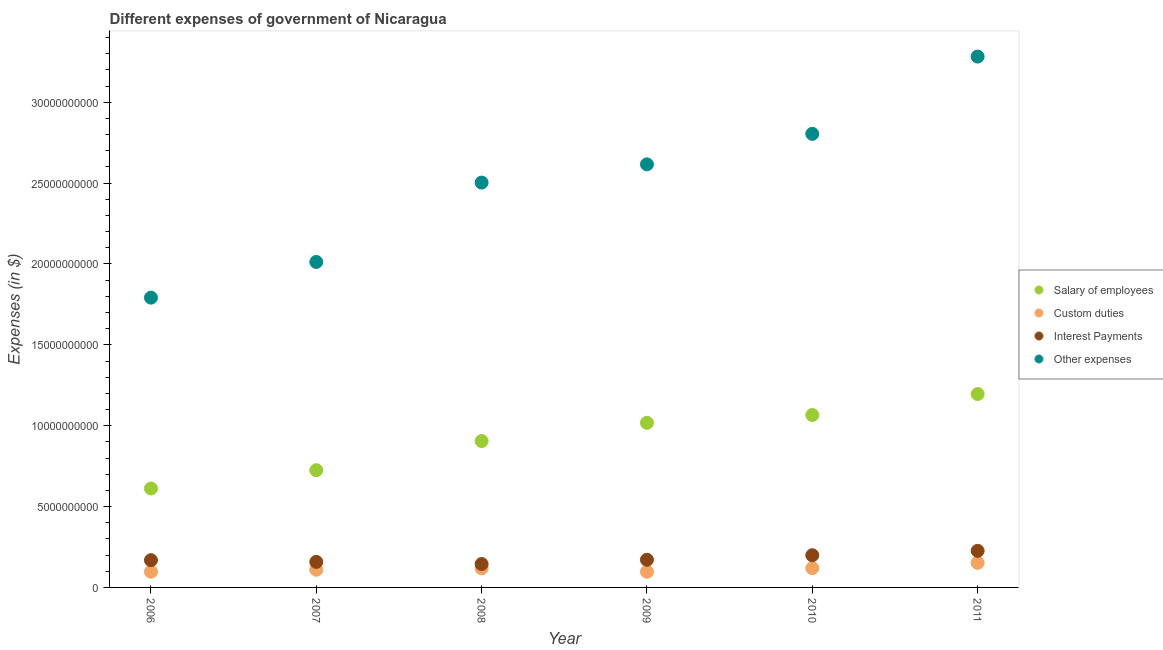How many different coloured dotlines are there?
Make the answer very short. 4. Is the number of dotlines equal to the number of legend labels?
Ensure brevity in your answer.  Yes. What is the amount spent on salary of employees in 2006?
Provide a succinct answer. 6.12e+09. Across all years, what is the maximum amount spent on salary of employees?
Offer a very short reply. 1.20e+1. Across all years, what is the minimum amount spent on salary of employees?
Keep it short and to the point. 6.12e+09. In which year was the amount spent on interest payments minimum?
Your answer should be very brief. 2008. What is the total amount spent on interest payments in the graph?
Keep it short and to the point. 1.07e+1. What is the difference between the amount spent on custom duties in 2006 and that in 2010?
Your answer should be very brief. -2.19e+08. What is the difference between the amount spent on interest payments in 2010 and the amount spent on salary of employees in 2006?
Make the answer very short. -4.13e+09. What is the average amount spent on custom duties per year?
Provide a short and direct response. 1.16e+09. In the year 2010, what is the difference between the amount spent on salary of employees and amount spent on interest payments?
Make the answer very short. 8.67e+09. In how many years, is the amount spent on salary of employees greater than 6000000000 $?
Make the answer very short. 6. What is the ratio of the amount spent on custom duties in 2006 to that in 2007?
Make the answer very short. 0.89. Is the amount spent on custom duties in 2009 less than that in 2011?
Your answer should be very brief. Yes. What is the difference between the highest and the second highest amount spent on custom duties?
Offer a terse response. 3.31e+08. What is the difference between the highest and the lowest amount spent on salary of employees?
Keep it short and to the point. 5.84e+09. In how many years, is the amount spent on salary of employees greater than the average amount spent on salary of employees taken over all years?
Your answer should be compact. 3. Is it the case that in every year, the sum of the amount spent on salary of employees and amount spent on other expenses is greater than the sum of amount spent on custom duties and amount spent on interest payments?
Your answer should be very brief. Yes. Is it the case that in every year, the sum of the amount spent on salary of employees and amount spent on custom duties is greater than the amount spent on interest payments?
Provide a short and direct response. Yes. Is the amount spent on custom duties strictly greater than the amount spent on other expenses over the years?
Provide a succinct answer. No. Is the amount spent on salary of employees strictly less than the amount spent on custom duties over the years?
Your response must be concise. No. How many dotlines are there?
Keep it short and to the point. 4. Are the values on the major ticks of Y-axis written in scientific E-notation?
Offer a very short reply. No. Does the graph contain any zero values?
Provide a short and direct response. No. How many legend labels are there?
Offer a terse response. 4. How are the legend labels stacked?
Your answer should be very brief. Vertical. What is the title of the graph?
Offer a very short reply. Different expenses of government of Nicaragua. Does "Grants and Revenue" appear as one of the legend labels in the graph?
Keep it short and to the point. No. What is the label or title of the X-axis?
Your answer should be compact. Year. What is the label or title of the Y-axis?
Offer a very short reply. Expenses (in $). What is the Expenses (in $) of Salary of employees in 2006?
Provide a succinct answer. 6.12e+09. What is the Expenses (in $) in Custom duties in 2006?
Provide a short and direct response. 9.72e+08. What is the Expenses (in $) in Interest Payments in 2006?
Your response must be concise. 1.68e+09. What is the Expenses (in $) in Other expenses in 2006?
Provide a short and direct response. 1.79e+1. What is the Expenses (in $) of Salary of employees in 2007?
Keep it short and to the point. 7.25e+09. What is the Expenses (in $) in Custom duties in 2007?
Give a very brief answer. 1.09e+09. What is the Expenses (in $) in Interest Payments in 2007?
Make the answer very short. 1.58e+09. What is the Expenses (in $) in Other expenses in 2007?
Offer a very short reply. 2.01e+1. What is the Expenses (in $) in Salary of employees in 2008?
Make the answer very short. 9.05e+09. What is the Expenses (in $) in Custom duties in 2008?
Make the answer very short. 1.18e+09. What is the Expenses (in $) in Interest Payments in 2008?
Offer a terse response. 1.45e+09. What is the Expenses (in $) in Other expenses in 2008?
Offer a terse response. 2.50e+1. What is the Expenses (in $) of Salary of employees in 2009?
Make the answer very short. 1.02e+1. What is the Expenses (in $) of Custom duties in 2009?
Your response must be concise. 9.70e+08. What is the Expenses (in $) in Interest Payments in 2009?
Keep it short and to the point. 1.71e+09. What is the Expenses (in $) in Other expenses in 2009?
Your response must be concise. 2.62e+1. What is the Expenses (in $) in Salary of employees in 2010?
Provide a succinct answer. 1.07e+1. What is the Expenses (in $) of Custom duties in 2010?
Provide a succinct answer. 1.19e+09. What is the Expenses (in $) of Interest Payments in 2010?
Make the answer very short. 1.99e+09. What is the Expenses (in $) in Other expenses in 2010?
Your response must be concise. 2.80e+1. What is the Expenses (in $) in Salary of employees in 2011?
Provide a succinct answer. 1.20e+1. What is the Expenses (in $) in Custom duties in 2011?
Offer a very short reply. 1.52e+09. What is the Expenses (in $) in Interest Payments in 2011?
Provide a succinct answer. 2.26e+09. What is the Expenses (in $) of Other expenses in 2011?
Give a very brief answer. 3.28e+1. Across all years, what is the maximum Expenses (in $) in Salary of employees?
Ensure brevity in your answer.  1.20e+1. Across all years, what is the maximum Expenses (in $) in Custom duties?
Offer a terse response. 1.52e+09. Across all years, what is the maximum Expenses (in $) of Interest Payments?
Provide a short and direct response. 2.26e+09. Across all years, what is the maximum Expenses (in $) of Other expenses?
Ensure brevity in your answer.  3.28e+1. Across all years, what is the minimum Expenses (in $) of Salary of employees?
Your answer should be compact. 6.12e+09. Across all years, what is the minimum Expenses (in $) in Custom duties?
Provide a short and direct response. 9.70e+08. Across all years, what is the minimum Expenses (in $) of Interest Payments?
Your answer should be compact. 1.45e+09. Across all years, what is the minimum Expenses (in $) in Other expenses?
Give a very brief answer. 1.79e+1. What is the total Expenses (in $) of Salary of employees in the graph?
Give a very brief answer. 5.52e+1. What is the total Expenses (in $) of Custom duties in the graph?
Provide a succinct answer. 6.93e+09. What is the total Expenses (in $) in Interest Payments in the graph?
Your answer should be very brief. 1.07e+1. What is the total Expenses (in $) of Other expenses in the graph?
Offer a terse response. 1.50e+11. What is the difference between the Expenses (in $) of Salary of employees in 2006 and that in 2007?
Your response must be concise. -1.13e+09. What is the difference between the Expenses (in $) in Custom duties in 2006 and that in 2007?
Make the answer very short. -1.21e+08. What is the difference between the Expenses (in $) in Interest Payments in 2006 and that in 2007?
Provide a short and direct response. 1.05e+08. What is the difference between the Expenses (in $) in Other expenses in 2006 and that in 2007?
Make the answer very short. -2.21e+09. What is the difference between the Expenses (in $) in Salary of employees in 2006 and that in 2008?
Ensure brevity in your answer.  -2.93e+09. What is the difference between the Expenses (in $) of Custom duties in 2006 and that in 2008?
Make the answer very short. -2.11e+08. What is the difference between the Expenses (in $) in Interest Payments in 2006 and that in 2008?
Your answer should be very brief. 2.37e+08. What is the difference between the Expenses (in $) of Other expenses in 2006 and that in 2008?
Offer a terse response. -7.11e+09. What is the difference between the Expenses (in $) in Salary of employees in 2006 and that in 2009?
Provide a succinct answer. -4.06e+09. What is the difference between the Expenses (in $) in Custom duties in 2006 and that in 2009?
Give a very brief answer. 1.82e+06. What is the difference between the Expenses (in $) of Interest Payments in 2006 and that in 2009?
Ensure brevity in your answer.  -2.69e+07. What is the difference between the Expenses (in $) of Other expenses in 2006 and that in 2009?
Ensure brevity in your answer.  -8.24e+09. What is the difference between the Expenses (in $) in Salary of employees in 2006 and that in 2010?
Provide a short and direct response. -4.54e+09. What is the difference between the Expenses (in $) in Custom duties in 2006 and that in 2010?
Provide a succinct answer. -2.19e+08. What is the difference between the Expenses (in $) in Interest Payments in 2006 and that in 2010?
Keep it short and to the point. -3.06e+08. What is the difference between the Expenses (in $) in Other expenses in 2006 and that in 2010?
Offer a very short reply. -1.01e+1. What is the difference between the Expenses (in $) of Salary of employees in 2006 and that in 2011?
Make the answer very short. -5.84e+09. What is the difference between the Expenses (in $) of Custom duties in 2006 and that in 2011?
Offer a very short reply. -5.50e+08. What is the difference between the Expenses (in $) of Interest Payments in 2006 and that in 2011?
Give a very brief answer. -5.78e+08. What is the difference between the Expenses (in $) of Other expenses in 2006 and that in 2011?
Offer a very short reply. -1.49e+1. What is the difference between the Expenses (in $) of Salary of employees in 2007 and that in 2008?
Give a very brief answer. -1.80e+09. What is the difference between the Expenses (in $) of Custom duties in 2007 and that in 2008?
Your answer should be compact. -8.99e+07. What is the difference between the Expenses (in $) in Interest Payments in 2007 and that in 2008?
Make the answer very short. 1.32e+08. What is the difference between the Expenses (in $) in Other expenses in 2007 and that in 2008?
Provide a short and direct response. -4.91e+09. What is the difference between the Expenses (in $) of Salary of employees in 2007 and that in 2009?
Ensure brevity in your answer.  -2.93e+09. What is the difference between the Expenses (in $) of Custom duties in 2007 and that in 2009?
Offer a very short reply. 1.23e+08. What is the difference between the Expenses (in $) of Interest Payments in 2007 and that in 2009?
Offer a terse response. -1.31e+08. What is the difference between the Expenses (in $) in Other expenses in 2007 and that in 2009?
Your answer should be very brief. -6.03e+09. What is the difference between the Expenses (in $) in Salary of employees in 2007 and that in 2010?
Ensure brevity in your answer.  -3.41e+09. What is the difference between the Expenses (in $) of Custom duties in 2007 and that in 2010?
Make the answer very short. -9.75e+07. What is the difference between the Expenses (in $) of Interest Payments in 2007 and that in 2010?
Offer a terse response. -4.11e+08. What is the difference between the Expenses (in $) in Other expenses in 2007 and that in 2010?
Your answer should be very brief. -7.92e+09. What is the difference between the Expenses (in $) in Salary of employees in 2007 and that in 2011?
Your response must be concise. -4.71e+09. What is the difference between the Expenses (in $) in Custom duties in 2007 and that in 2011?
Your answer should be compact. -4.29e+08. What is the difference between the Expenses (in $) of Interest Payments in 2007 and that in 2011?
Provide a short and direct response. -6.82e+08. What is the difference between the Expenses (in $) of Other expenses in 2007 and that in 2011?
Make the answer very short. -1.27e+1. What is the difference between the Expenses (in $) in Salary of employees in 2008 and that in 2009?
Keep it short and to the point. -1.13e+09. What is the difference between the Expenses (in $) of Custom duties in 2008 and that in 2009?
Make the answer very short. 2.13e+08. What is the difference between the Expenses (in $) of Interest Payments in 2008 and that in 2009?
Ensure brevity in your answer.  -2.64e+08. What is the difference between the Expenses (in $) in Other expenses in 2008 and that in 2009?
Offer a terse response. -1.13e+09. What is the difference between the Expenses (in $) in Salary of employees in 2008 and that in 2010?
Provide a short and direct response. -1.61e+09. What is the difference between the Expenses (in $) in Custom duties in 2008 and that in 2010?
Give a very brief answer. -7.60e+06. What is the difference between the Expenses (in $) in Interest Payments in 2008 and that in 2010?
Offer a terse response. -5.43e+08. What is the difference between the Expenses (in $) of Other expenses in 2008 and that in 2010?
Keep it short and to the point. -3.01e+09. What is the difference between the Expenses (in $) in Salary of employees in 2008 and that in 2011?
Your answer should be compact. -2.91e+09. What is the difference between the Expenses (in $) in Custom duties in 2008 and that in 2011?
Make the answer very short. -3.39e+08. What is the difference between the Expenses (in $) in Interest Payments in 2008 and that in 2011?
Offer a very short reply. -8.14e+08. What is the difference between the Expenses (in $) of Other expenses in 2008 and that in 2011?
Keep it short and to the point. -7.79e+09. What is the difference between the Expenses (in $) in Salary of employees in 2009 and that in 2010?
Make the answer very short. -4.83e+08. What is the difference between the Expenses (in $) in Custom duties in 2009 and that in 2010?
Offer a very short reply. -2.21e+08. What is the difference between the Expenses (in $) of Interest Payments in 2009 and that in 2010?
Your response must be concise. -2.79e+08. What is the difference between the Expenses (in $) of Other expenses in 2009 and that in 2010?
Ensure brevity in your answer.  -1.89e+09. What is the difference between the Expenses (in $) of Salary of employees in 2009 and that in 2011?
Ensure brevity in your answer.  -1.78e+09. What is the difference between the Expenses (in $) of Custom duties in 2009 and that in 2011?
Keep it short and to the point. -5.52e+08. What is the difference between the Expenses (in $) in Interest Payments in 2009 and that in 2011?
Provide a short and direct response. -5.51e+08. What is the difference between the Expenses (in $) in Other expenses in 2009 and that in 2011?
Make the answer very short. -6.66e+09. What is the difference between the Expenses (in $) of Salary of employees in 2010 and that in 2011?
Ensure brevity in your answer.  -1.30e+09. What is the difference between the Expenses (in $) in Custom duties in 2010 and that in 2011?
Provide a succinct answer. -3.31e+08. What is the difference between the Expenses (in $) in Interest Payments in 2010 and that in 2011?
Offer a very short reply. -2.71e+08. What is the difference between the Expenses (in $) of Other expenses in 2010 and that in 2011?
Your answer should be compact. -4.78e+09. What is the difference between the Expenses (in $) of Salary of employees in 2006 and the Expenses (in $) of Custom duties in 2007?
Offer a very short reply. 5.02e+09. What is the difference between the Expenses (in $) of Salary of employees in 2006 and the Expenses (in $) of Interest Payments in 2007?
Provide a succinct answer. 4.54e+09. What is the difference between the Expenses (in $) of Salary of employees in 2006 and the Expenses (in $) of Other expenses in 2007?
Provide a short and direct response. -1.40e+1. What is the difference between the Expenses (in $) in Custom duties in 2006 and the Expenses (in $) in Interest Payments in 2007?
Give a very brief answer. -6.08e+08. What is the difference between the Expenses (in $) of Custom duties in 2006 and the Expenses (in $) of Other expenses in 2007?
Make the answer very short. -1.92e+1. What is the difference between the Expenses (in $) of Interest Payments in 2006 and the Expenses (in $) of Other expenses in 2007?
Your answer should be compact. -1.84e+1. What is the difference between the Expenses (in $) in Salary of employees in 2006 and the Expenses (in $) in Custom duties in 2008?
Keep it short and to the point. 4.93e+09. What is the difference between the Expenses (in $) of Salary of employees in 2006 and the Expenses (in $) of Interest Payments in 2008?
Offer a terse response. 4.67e+09. What is the difference between the Expenses (in $) of Salary of employees in 2006 and the Expenses (in $) of Other expenses in 2008?
Your response must be concise. -1.89e+1. What is the difference between the Expenses (in $) in Custom duties in 2006 and the Expenses (in $) in Interest Payments in 2008?
Keep it short and to the point. -4.75e+08. What is the difference between the Expenses (in $) in Custom duties in 2006 and the Expenses (in $) in Other expenses in 2008?
Provide a short and direct response. -2.41e+1. What is the difference between the Expenses (in $) of Interest Payments in 2006 and the Expenses (in $) of Other expenses in 2008?
Make the answer very short. -2.33e+1. What is the difference between the Expenses (in $) in Salary of employees in 2006 and the Expenses (in $) in Custom duties in 2009?
Ensure brevity in your answer.  5.15e+09. What is the difference between the Expenses (in $) in Salary of employees in 2006 and the Expenses (in $) in Interest Payments in 2009?
Your answer should be very brief. 4.41e+09. What is the difference between the Expenses (in $) in Salary of employees in 2006 and the Expenses (in $) in Other expenses in 2009?
Make the answer very short. -2.00e+1. What is the difference between the Expenses (in $) of Custom duties in 2006 and the Expenses (in $) of Interest Payments in 2009?
Ensure brevity in your answer.  -7.39e+08. What is the difference between the Expenses (in $) of Custom duties in 2006 and the Expenses (in $) of Other expenses in 2009?
Give a very brief answer. -2.52e+1. What is the difference between the Expenses (in $) of Interest Payments in 2006 and the Expenses (in $) of Other expenses in 2009?
Keep it short and to the point. -2.45e+1. What is the difference between the Expenses (in $) in Salary of employees in 2006 and the Expenses (in $) in Custom duties in 2010?
Ensure brevity in your answer.  4.93e+09. What is the difference between the Expenses (in $) in Salary of employees in 2006 and the Expenses (in $) in Interest Payments in 2010?
Offer a terse response. 4.13e+09. What is the difference between the Expenses (in $) in Salary of employees in 2006 and the Expenses (in $) in Other expenses in 2010?
Offer a very short reply. -2.19e+1. What is the difference between the Expenses (in $) of Custom duties in 2006 and the Expenses (in $) of Interest Payments in 2010?
Keep it short and to the point. -1.02e+09. What is the difference between the Expenses (in $) in Custom duties in 2006 and the Expenses (in $) in Other expenses in 2010?
Give a very brief answer. -2.71e+1. What is the difference between the Expenses (in $) in Interest Payments in 2006 and the Expenses (in $) in Other expenses in 2010?
Your answer should be compact. -2.64e+1. What is the difference between the Expenses (in $) in Salary of employees in 2006 and the Expenses (in $) in Custom duties in 2011?
Your answer should be compact. 4.60e+09. What is the difference between the Expenses (in $) in Salary of employees in 2006 and the Expenses (in $) in Interest Payments in 2011?
Offer a terse response. 3.86e+09. What is the difference between the Expenses (in $) of Salary of employees in 2006 and the Expenses (in $) of Other expenses in 2011?
Provide a succinct answer. -2.67e+1. What is the difference between the Expenses (in $) in Custom duties in 2006 and the Expenses (in $) in Interest Payments in 2011?
Offer a terse response. -1.29e+09. What is the difference between the Expenses (in $) in Custom duties in 2006 and the Expenses (in $) in Other expenses in 2011?
Provide a short and direct response. -3.19e+1. What is the difference between the Expenses (in $) in Interest Payments in 2006 and the Expenses (in $) in Other expenses in 2011?
Provide a succinct answer. -3.11e+1. What is the difference between the Expenses (in $) in Salary of employees in 2007 and the Expenses (in $) in Custom duties in 2008?
Your response must be concise. 6.06e+09. What is the difference between the Expenses (in $) in Salary of employees in 2007 and the Expenses (in $) in Interest Payments in 2008?
Offer a very short reply. 5.80e+09. What is the difference between the Expenses (in $) of Salary of employees in 2007 and the Expenses (in $) of Other expenses in 2008?
Keep it short and to the point. -1.78e+1. What is the difference between the Expenses (in $) of Custom duties in 2007 and the Expenses (in $) of Interest Payments in 2008?
Keep it short and to the point. -3.54e+08. What is the difference between the Expenses (in $) in Custom duties in 2007 and the Expenses (in $) in Other expenses in 2008?
Give a very brief answer. -2.39e+1. What is the difference between the Expenses (in $) in Interest Payments in 2007 and the Expenses (in $) in Other expenses in 2008?
Make the answer very short. -2.35e+1. What is the difference between the Expenses (in $) of Salary of employees in 2007 and the Expenses (in $) of Custom duties in 2009?
Offer a terse response. 6.28e+09. What is the difference between the Expenses (in $) in Salary of employees in 2007 and the Expenses (in $) in Interest Payments in 2009?
Your response must be concise. 5.54e+09. What is the difference between the Expenses (in $) of Salary of employees in 2007 and the Expenses (in $) of Other expenses in 2009?
Your response must be concise. -1.89e+1. What is the difference between the Expenses (in $) of Custom duties in 2007 and the Expenses (in $) of Interest Payments in 2009?
Make the answer very short. -6.18e+08. What is the difference between the Expenses (in $) of Custom duties in 2007 and the Expenses (in $) of Other expenses in 2009?
Give a very brief answer. -2.51e+1. What is the difference between the Expenses (in $) of Interest Payments in 2007 and the Expenses (in $) of Other expenses in 2009?
Your response must be concise. -2.46e+1. What is the difference between the Expenses (in $) of Salary of employees in 2007 and the Expenses (in $) of Custom duties in 2010?
Ensure brevity in your answer.  6.06e+09. What is the difference between the Expenses (in $) in Salary of employees in 2007 and the Expenses (in $) in Interest Payments in 2010?
Your answer should be very brief. 5.26e+09. What is the difference between the Expenses (in $) in Salary of employees in 2007 and the Expenses (in $) in Other expenses in 2010?
Keep it short and to the point. -2.08e+1. What is the difference between the Expenses (in $) in Custom duties in 2007 and the Expenses (in $) in Interest Payments in 2010?
Offer a very short reply. -8.97e+08. What is the difference between the Expenses (in $) of Custom duties in 2007 and the Expenses (in $) of Other expenses in 2010?
Give a very brief answer. -2.70e+1. What is the difference between the Expenses (in $) of Interest Payments in 2007 and the Expenses (in $) of Other expenses in 2010?
Offer a terse response. -2.65e+1. What is the difference between the Expenses (in $) of Salary of employees in 2007 and the Expenses (in $) of Custom duties in 2011?
Give a very brief answer. 5.73e+09. What is the difference between the Expenses (in $) in Salary of employees in 2007 and the Expenses (in $) in Interest Payments in 2011?
Ensure brevity in your answer.  4.99e+09. What is the difference between the Expenses (in $) in Salary of employees in 2007 and the Expenses (in $) in Other expenses in 2011?
Provide a short and direct response. -2.56e+1. What is the difference between the Expenses (in $) in Custom duties in 2007 and the Expenses (in $) in Interest Payments in 2011?
Ensure brevity in your answer.  -1.17e+09. What is the difference between the Expenses (in $) in Custom duties in 2007 and the Expenses (in $) in Other expenses in 2011?
Your response must be concise. -3.17e+1. What is the difference between the Expenses (in $) in Interest Payments in 2007 and the Expenses (in $) in Other expenses in 2011?
Your answer should be very brief. -3.12e+1. What is the difference between the Expenses (in $) in Salary of employees in 2008 and the Expenses (in $) in Custom duties in 2009?
Keep it short and to the point. 8.08e+09. What is the difference between the Expenses (in $) of Salary of employees in 2008 and the Expenses (in $) of Interest Payments in 2009?
Ensure brevity in your answer.  7.34e+09. What is the difference between the Expenses (in $) in Salary of employees in 2008 and the Expenses (in $) in Other expenses in 2009?
Give a very brief answer. -1.71e+1. What is the difference between the Expenses (in $) of Custom duties in 2008 and the Expenses (in $) of Interest Payments in 2009?
Give a very brief answer. -5.28e+08. What is the difference between the Expenses (in $) in Custom duties in 2008 and the Expenses (in $) in Other expenses in 2009?
Offer a very short reply. -2.50e+1. What is the difference between the Expenses (in $) of Interest Payments in 2008 and the Expenses (in $) of Other expenses in 2009?
Your response must be concise. -2.47e+1. What is the difference between the Expenses (in $) of Salary of employees in 2008 and the Expenses (in $) of Custom duties in 2010?
Provide a short and direct response. 7.86e+09. What is the difference between the Expenses (in $) of Salary of employees in 2008 and the Expenses (in $) of Interest Payments in 2010?
Offer a terse response. 7.06e+09. What is the difference between the Expenses (in $) of Salary of employees in 2008 and the Expenses (in $) of Other expenses in 2010?
Keep it short and to the point. -1.90e+1. What is the difference between the Expenses (in $) of Custom duties in 2008 and the Expenses (in $) of Interest Payments in 2010?
Offer a very short reply. -8.07e+08. What is the difference between the Expenses (in $) of Custom duties in 2008 and the Expenses (in $) of Other expenses in 2010?
Your answer should be very brief. -2.69e+1. What is the difference between the Expenses (in $) of Interest Payments in 2008 and the Expenses (in $) of Other expenses in 2010?
Your response must be concise. -2.66e+1. What is the difference between the Expenses (in $) of Salary of employees in 2008 and the Expenses (in $) of Custom duties in 2011?
Keep it short and to the point. 7.53e+09. What is the difference between the Expenses (in $) in Salary of employees in 2008 and the Expenses (in $) in Interest Payments in 2011?
Provide a succinct answer. 6.79e+09. What is the difference between the Expenses (in $) of Salary of employees in 2008 and the Expenses (in $) of Other expenses in 2011?
Ensure brevity in your answer.  -2.38e+1. What is the difference between the Expenses (in $) of Custom duties in 2008 and the Expenses (in $) of Interest Payments in 2011?
Ensure brevity in your answer.  -1.08e+09. What is the difference between the Expenses (in $) in Custom duties in 2008 and the Expenses (in $) in Other expenses in 2011?
Your response must be concise. -3.16e+1. What is the difference between the Expenses (in $) in Interest Payments in 2008 and the Expenses (in $) in Other expenses in 2011?
Provide a succinct answer. -3.14e+1. What is the difference between the Expenses (in $) in Salary of employees in 2009 and the Expenses (in $) in Custom duties in 2010?
Give a very brief answer. 8.99e+09. What is the difference between the Expenses (in $) in Salary of employees in 2009 and the Expenses (in $) in Interest Payments in 2010?
Provide a short and direct response. 8.19e+09. What is the difference between the Expenses (in $) of Salary of employees in 2009 and the Expenses (in $) of Other expenses in 2010?
Offer a very short reply. -1.79e+1. What is the difference between the Expenses (in $) in Custom duties in 2009 and the Expenses (in $) in Interest Payments in 2010?
Make the answer very short. -1.02e+09. What is the difference between the Expenses (in $) in Custom duties in 2009 and the Expenses (in $) in Other expenses in 2010?
Give a very brief answer. -2.71e+1. What is the difference between the Expenses (in $) in Interest Payments in 2009 and the Expenses (in $) in Other expenses in 2010?
Your answer should be very brief. -2.63e+1. What is the difference between the Expenses (in $) of Salary of employees in 2009 and the Expenses (in $) of Custom duties in 2011?
Provide a succinct answer. 8.66e+09. What is the difference between the Expenses (in $) of Salary of employees in 2009 and the Expenses (in $) of Interest Payments in 2011?
Provide a succinct answer. 7.92e+09. What is the difference between the Expenses (in $) in Salary of employees in 2009 and the Expenses (in $) in Other expenses in 2011?
Provide a succinct answer. -2.26e+1. What is the difference between the Expenses (in $) in Custom duties in 2009 and the Expenses (in $) in Interest Payments in 2011?
Your response must be concise. -1.29e+09. What is the difference between the Expenses (in $) in Custom duties in 2009 and the Expenses (in $) in Other expenses in 2011?
Provide a short and direct response. -3.19e+1. What is the difference between the Expenses (in $) in Interest Payments in 2009 and the Expenses (in $) in Other expenses in 2011?
Offer a very short reply. -3.11e+1. What is the difference between the Expenses (in $) of Salary of employees in 2010 and the Expenses (in $) of Custom duties in 2011?
Give a very brief answer. 9.14e+09. What is the difference between the Expenses (in $) of Salary of employees in 2010 and the Expenses (in $) of Interest Payments in 2011?
Offer a very short reply. 8.40e+09. What is the difference between the Expenses (in $) of Salary of employees in 2010 and the Expenses (in $) of Other expenses in 2011?
Your response must be concise. -2.22e+1. What is the difference between the Expenses (in $) in Custom duties in 2010 and the Expenses (in $) in Interest Payments in 2011?
Offer a very short reply. -1.07e+09. What is the difference between the Expenses (in $) in Custom duties in 2010 and the Expenses (in $) in Other expenses in 2011?
Your answer should be compact. -3.16e+1. What is the difference between the Expenses (in $) in Interest Payments in 2010 and the Expenses (in $) in Other expenses in 2011?
Your response must be concise. -3.08e+1. What is the average Expenses (in $) of Salary of employees per year?
Make the answer very short. 9.20e+09. What is the average Expenses (in $) in Custom duties per year?
Your answer should be very brief. 1.16e+09. What is the average Expenses (in $) of Interest Payments per year?
Your answer should be very brief. 1.78e+09. What is the average Expenses (in $) in Other expenses per year?
Provide a succinct answer. 2.50e+1. In the year 2006, what is the difference between the Expenses (in $) in Salary of employees and Expenses (in $) in Custom duties?
Your answer should be compact. 5.15e+09. In the year 2006, what is the difference between the Expenses (in $) in Salary of employees and Expenses (in $) in Interest Payments?
Your answer should be very brief. 4.43e+09. In the year 2006, what is the difference between the Expenses (in $) of Salary of employees and Expenses (in $) of Other expenses?
Offer a terse response. -1.18e+1. In the year 2006, what is the difference between the Expenses (in $) of Custom duties and Expenses (in $) of Interest Payments?
Provide a short and direct response. -7.12e+08. In the year 2006, what is the difference between the Expenses (in $) in Custom duties and Expenses (in $) in Other expenses?
Your answer should be compact. -1.69e+1. In the year 2006, what is the difference between the Expenses (in $) in Interest Payments and Expenses (in $) in Other expenses?
Your answer should be compact. -1.62e+1. In the year 2007, what is the difference between the Expenses (in $) in Salary of employees and Expenses (in $) in Custom duties?
Ensure brevity in your answer.  6.15e+09. In the year 2007, what is the difference between the Expenses (in $) in Salary of employees and Expenses (in $) in Interest Payments?
Keep it short and to the point. 5.67e+09. In the year 2007, what is the difference between the Expenses (in $) of Salary of employees and Expenses (in $) of Other expenses?
Make the answer very short. -1.29e+1. In the year 2007, what is the difference between the Expenses (in $) in Custom duties and Expenses (in $) in Interest Payments?
Ensure brevity in your answer.  -4.86e+08. In the year 2007, what is the difference between the Expenses (in $) of Custom duties and Expenses (in $) of Other expenses?
Keep it short and to the point. -1.90e+1. In the year 2007, what is the difference between the Expenses (in $) of Interest Payments and Expenses (in $) of Other expenses?
Give a very brief answer. -1.85e+1. In the year 2008, what is the difference between the Expenses (in $) in Salary of employees and Expenses (in $) in Custom duties?
Make the answer very short. 7.87e+09. In the year 2008, what is the difference between the Expenses (in $) of Salary of employees and Expenses (in $) of Interest Payments?
Ensure brevity in your answer.  7.60e+09. In the year 2008, what is the difference between the Expenses (in $) of Salary of employees and Expenses (in $) of Other expenses?
Your answer should be very brief. -1.60e+1. In the year 2008, what is the difference between the Expenses (in $) in Custom duties and Expenses (in $) in Interest Payments?
Your response must be concise. -2.64e+08. In the year 2008, what is the difference between the Expenses (in $) of Custom duties and Expenses (in $) of Other expenses?
Ensure brevity in your answer.  -2.38e+1. In the year 2008, what is the difference between the Expenses (in $) of Interest Payments and Expenses (in $) of Other expenses?
Make the answer very short. -2.36e+1. In the year 2009, what is the difference between the Expenses (in $) of Salary of employees and Expenses (in $) of Custom duties?
Provide a short and direct response. 9.21e+09. In the year 2009, what is the difference between the Expenses (in $) in Salary of employees and Expenses (in $) in Interest Payments?
Offer a terse response. 8.47e+09. In the year 2009, what is the difference between the Expenses (in $) of Salary of employees and Expenses (in $) of Other expenses?
Provide a short and direct response. -1.60e+1. In the year 2009, what is the difference between the Expenses (in $) in Custom duties and Expenses (in $) in Interest Payments?
Your answer should be compact. -7.41e+08. In the year 2009, what is the difference between the Expenses (in $) in Custom duties and Expenses (in $) in Other expenses?
Offer a terse response. -2.52e+1. In the year 2009, what is the difference between the Expenses (in $) in Interest Payments and Expenses (in $) in Other expenses?
Make the answer very short. -2.44e+1. In the year 2010, what is the difference between the Expenses (in $) in Salary of employees and Expenses (in $) in Custom duties?
Provide a succinct answer. 9.47e+09. In the year 2010, what is the difference between the Expenses (in $) in Salary of employees and Expenses (in $) in Interest Payments?
Your answer should be very brief. 8.67e+09. In the year 2010, what is the difference between the Expenses (in $) in Salary of employees and Expenses (in $) in Other expenses?
Your response must be concise. -1.74e+1. In the year 2010, what is the difference between the Expenses (in $) in Custom duties and Expenses (in $) in Interest Payments?
Your response must be concise. -8.00e+08. In the year 2010, what is the difference between the Expenses (in $) of Custom duties and Expenses (in $) of Other expenses?
Offer a very short reply. -2.69e+1. In the year 2010, what is the difference between the Expenses (in $) of Interest Payments and Expenses (in $) of Other expenses?
Your answer should be very brief. -2.61e+1. In the year 2011, what is the difference between the Expenses (in $) in Salary of employees and Expenses (in $) in Custom duties?
Offer a very short reply. 1.04e+1. In the year 2011, what is the difference between the Expenses (in $) in Salary of employees and Expenses (in $) in Interest Payments?
Your answer should be compact. 9.70e+09. In the year 2011, what is the difference between the Expenses (in $) in Salary of employees and Expenses (in $) in Other expenses?
Offer a very short reply. -2.09e+1. In the year 2011, what is the difference between the Expenses (in $) in Custom duties and Expenses (in $) in Interest Payments?
Your answer should be compact. -7.40e+08. In the year 2011, what is the difference between the Expenses (in $) in Custom duties and Expenses (in $) in Other expenses?
Keep it short and to the point. -3.13e+1. In the year 2011, what is the difference between the Expenses (in $) in Interest Payments and Expenses (in $) in Other expenses?
Your answer should be very brief. -3.06e+1. What is the ratio of the Expenses (in $) of Salary of employees in 2006 to that in 2007?
Ensure brevity in your answer.  0.84. What is the ratio of the Expenses (in $) in Custom duties in 2006 to that in 2007?
Your answer should be very brief. 0.89. What is the ratio of the Expenses (in $) of Interest Payments in 2006 to that in 2007?
Give a very brief answer. 1.07. What is the ratio of the Expenses (in $) of Other expenses in 2006 to that in 2007?
Your answer should be very brief. 0.89. What is the ratio of the Expenses (in $) in Salary of employees in 2006 to that in 2008?
Keep it short and to the point. 0.68. What is the ratio of the Expenses (in $) in Custom duties in 2006 to that in 2008?
Provide a succinct answer. 0.82. What is the ratio of the Expenses (in $) of Interest Payments in 2006 to that in 2008?
Keep it short and to the point. 1.16. What is the ratio of the Expenses (in $) in Other expenses in 2006 to that in 2008?
Provide a short and direct response. 0.72. What is the ratio of the Expenses (in $) of Salary of employees in 2006 to that in 2009?
Provide a short and direct response. 0.6. What is the ratio of the Expenses (in $) in Interest Payments in 2006 to that in 2009?
Provide a short and direct response. 0.98. What is the ratio of the Expenses (in $) in Other expenses in 2006 to that in 2009?
Offer a terse response. 0.69. What is the ratio of the Expenses (in $) of Salary of employees in 2006 to that in 2010?
Ensure brevity in your answer.  0.57. What is the ratio of the Expenses (in $) in Custom duties in 2006 to that in 2010?
Offer a terse response. 0.82. What is the ratio of the Expenses (in $) in Interest Payments in 2006 to that in 2010?
Offer a very short reply. 0.85. What is the ratio of the Expenses (in $) in Other expenses in 2006 to that in 2010?
Your answer should be compact. 0.64. What is the ratio of the Expenses (in $) in Salary of employees in 2006 to that in 2011?
Provide a short and direct response. 0.51. What is the ratio of the Expenses (in $) in Custom duties in 2006 to that in 2011?
Make the answer very short. 0.64. What is the ratio of the Expenses (in $) of Interest Payments in 2006 to that in 2011?
Offer a terse response. 0.74. What is the ratio of the Expenses (in $) in Other expenses in 2006 to that in 2011?
Your response must be concise. 0.55. What is the ratio of the Expenses (in $) of Salary of employees in 2007 to that in 2008?
Your answer should be very brief. 0.8. What is the ratio of the Expenses (in $) in Custom duties in 2007 to that in 2008?
Make the answer very short. 0.92. What is the ratio of the Expenses (in $) of Interest Payments in 2007 to that in 2008?
Offer a very short reply. 1.09. What is the ratio of the Expenses (in $) in Other expenses in 2007 to that in 2008?
Your answer should be compact. 0.8. What is the ratio of the Expenses (in $) of Salary of employees in 2007 to that in 2009?
Give a very brief answer. 0.71. What is the ratio of the Expenses (in $) in Custom duties in 2007 to that in 2009?
Provide a short and direct response. 1.13. What is the ratio of the Expenses (in $) of Interest Payments in 2007 to that in 2009?
Your response must be concise. 0.92. What is the ratio of the Expenses (in $) of Other expenses in 2007 to that in 2009?
Make the answer very short. 0.77. What is the ratio of the Expenses (in $) of Salary of employees in 2007 to that in 2010?
Give a very brief answer. 0.68. What is the ratio of the Expenses (in $) of Custom duties in 2007 to that in 2010?
Keep it short and to the point. 0.92. What is the ratio of the Expenses (in $) of Interest Payments in 2007 to that in 2010?
Provide a succinct answer. 0.79. What is the ratio of the Expenses (in $) of Other expenses in 2007 to that in 2010?
Provide a short and direct response. 0.72. What is the ratio of the Expenses (in $) in Salary of employees in 2007 to that in 2011?
Provide a succinct answer. 0.61. What is the ratio of the Expenses (in $) in Custom duties in 2007 to that in 2011?
Ensure brevity in your answer.  0.72. What is the ratio of the Expenses (in $) of Interest Payments in 2007 to that in 2011?
Your answer should be compact. 0.7. What is the ratio of the Expenses (in $) in Other expenses in 2007 to that in 2011?
Your answer should be compact. 0.61. What is the ratio of the Expenses (in $) in Salary of employees in 2008 to that in 2009?
Provide a short and direct response. 0.89. What is the ratio of the Expenses (in $) of Custom duties in 2008 to that in 2009?
Ensure brevity in your answer.  1.22. What is the ratio of the Expenses (in $) of Interest Payments in 2008 to that in 2009?
Offer a terse response. 0.85. What is the ratio of the Expenses (in $) in Other expenses in 2008 to that in 2009?
Your answer should be compact. 0.96. What is the ratio of the Expenses (in $) in Salary of employees in 2008 to that in 2010?
Provide a short and direct response. 0.85. What is the ratio of the Expenses (in $) of Interest Payments in 2008 to that in 2010?
Offer a terse response. 0.73. What is the ratio of the Expenses (in $) in Other expenses in 2008 to that in 2010?
Provide a short and direct response. 0.89. What is the ratio of the Expenses (in $) in Salary of employees in 2008 to that in 2011?
Provide a succinct answer. 0.76. What is the ratio of the Expenses (in $) of Custom duties in 2008 to that in 2011?
Provide a succinct answer. 0.78. What is the ratio of the Expenses (in $) in Interest Payments in 2008 to that in 2011?
Ensure brevity in your answer.  0.64. What is the ratio of the Expenses (in $) of Other expenses in 2008 to that in 2011?
Provide a short and direct response. 0.76. What is the ratio of the Expenses (in $) in Salary of employees in 2009 to that in 2010?
Ensure brevity in your answer.  0.95. What is the ratio of the Expenses (in $) of Custom duties in 2009 to that in 2010?
Keep it short and to the point. 0.81. What is the ratio of the Expenses (in $) in Interest Payments in 2009 to that in 2010?
Make the answer very short. 0.86. What is the ratio of the Expenses (in $) in Other expenses in 2009 to that in 2010?
Offer a very short reply. 0.93. What is the ratio of the Expenses (in $) of Salary of employees in 2009 to that in 2011?
Ensure brevity in your answer.  0.85. What is the ratio of the Expenses (in $) of Custom duties in 2009 to that in 2011?
Offer a terse response. 0.64. What is the ratio of the Expenses (in $) of Interest Payments in 2009 to that in 2011?
Make the answer very short. 0.76. What is the ratio of the Expenses (in $) in Other expenses in 2009 to that in 2011?
Give a very brief answer. 0.8. What is the ratio of the Expenses (in $) of Salary of employees in 2010 to that in 2011?
Your answer should be compact. 0.89. What is the ratio of the Expenses (in $) in Custom duties in 2010 to that in 2011?
Offer a very short reply. 0.78. What is the ratio of the Expenses (in $) of Interest Payments in 2010 to that in 2011?
Make the answer very short. 0.88. What is the ratio of the Expenses (in $) in Other expenses in 2010 to that in 2011?
Your response must be concise. 0.85. What is the difference between the highest and the second highest Expenses (in $) in Salary of employees?
Give a very brief answer. 1.30e+09. What is the difference between the highest and the second highest Expenses (in $) in Custom duties?
Provide a short and direct response. 3.31e+08. What is the difference between the highest and the second highest Expenses (in $) of Interest Payments?
Ensure brevity in your answer.  2.71e+08. What is the difference between the highest and the second highest Expenses (in $) of Other expenses?
Give a very brief answer. 4.78e+09. What is the difference between the highest and the lowest Expenses (in $) in Salary of employees?
Your answer should be very brief. 5.84e+09. What is the difference between the highest and the lowest Expenses (in $) in Custom duties?
Ensure brevity in your answer.  5.52e+08. What is the difference between the highest and the lowest Expenses (in $) in Interest Payments?
Your answer should be very brief. 8.14e+08. What is the difference between the highest and the lowest Expenses (in $) in Other expenses?
Offer a very short reply. 1.49e+1. 